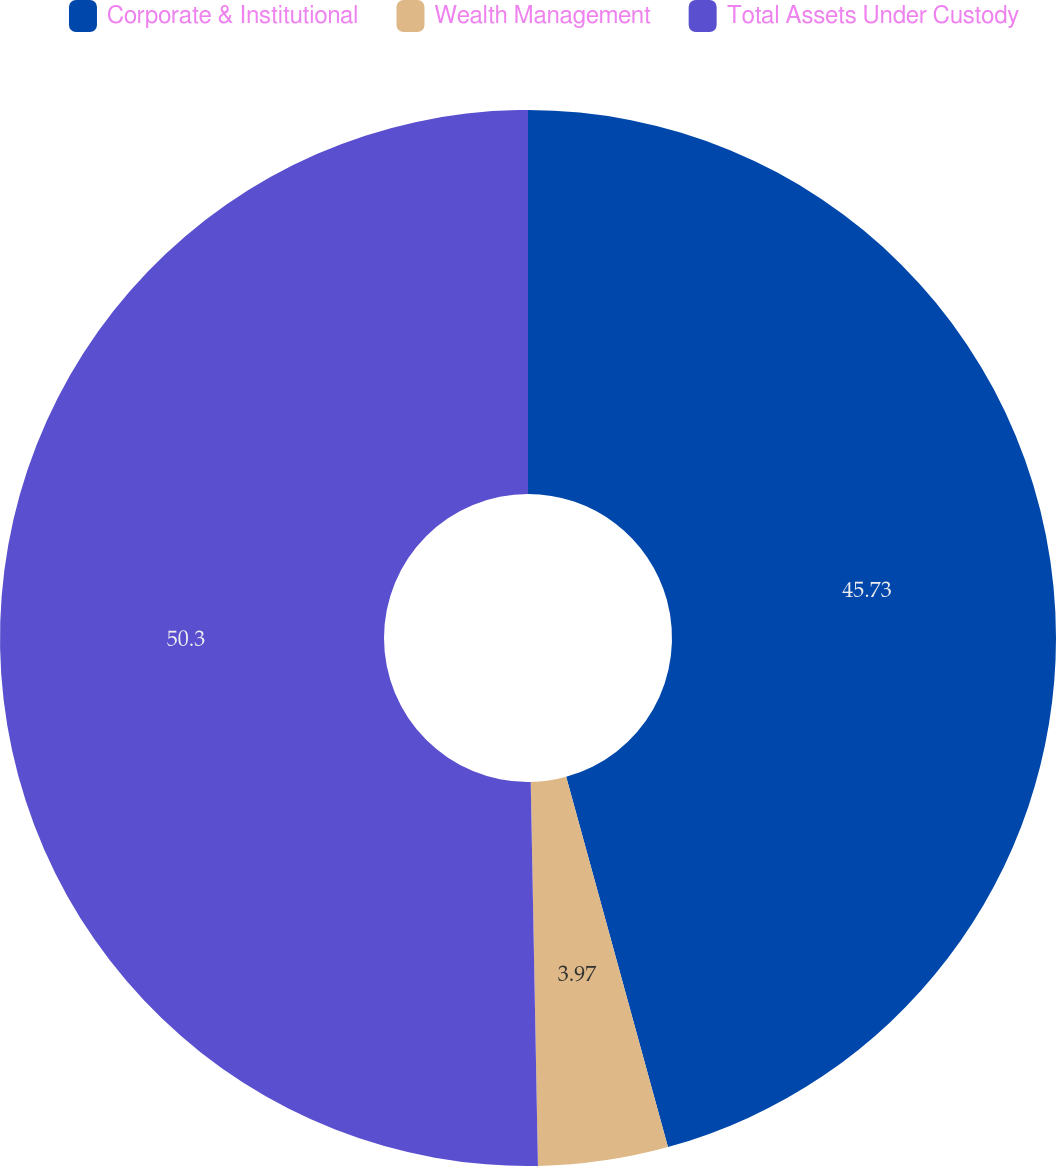<chart> <loc_0><loc_0><loc_500><loc_500><pie_chart><fcel>Corporate & Institutional<fcel>Wealth Management<fcel>Total Assets Under Custody<nl><fcel>45.73%<fcel>3.97%<fcel>50.3%<nl></chart> 